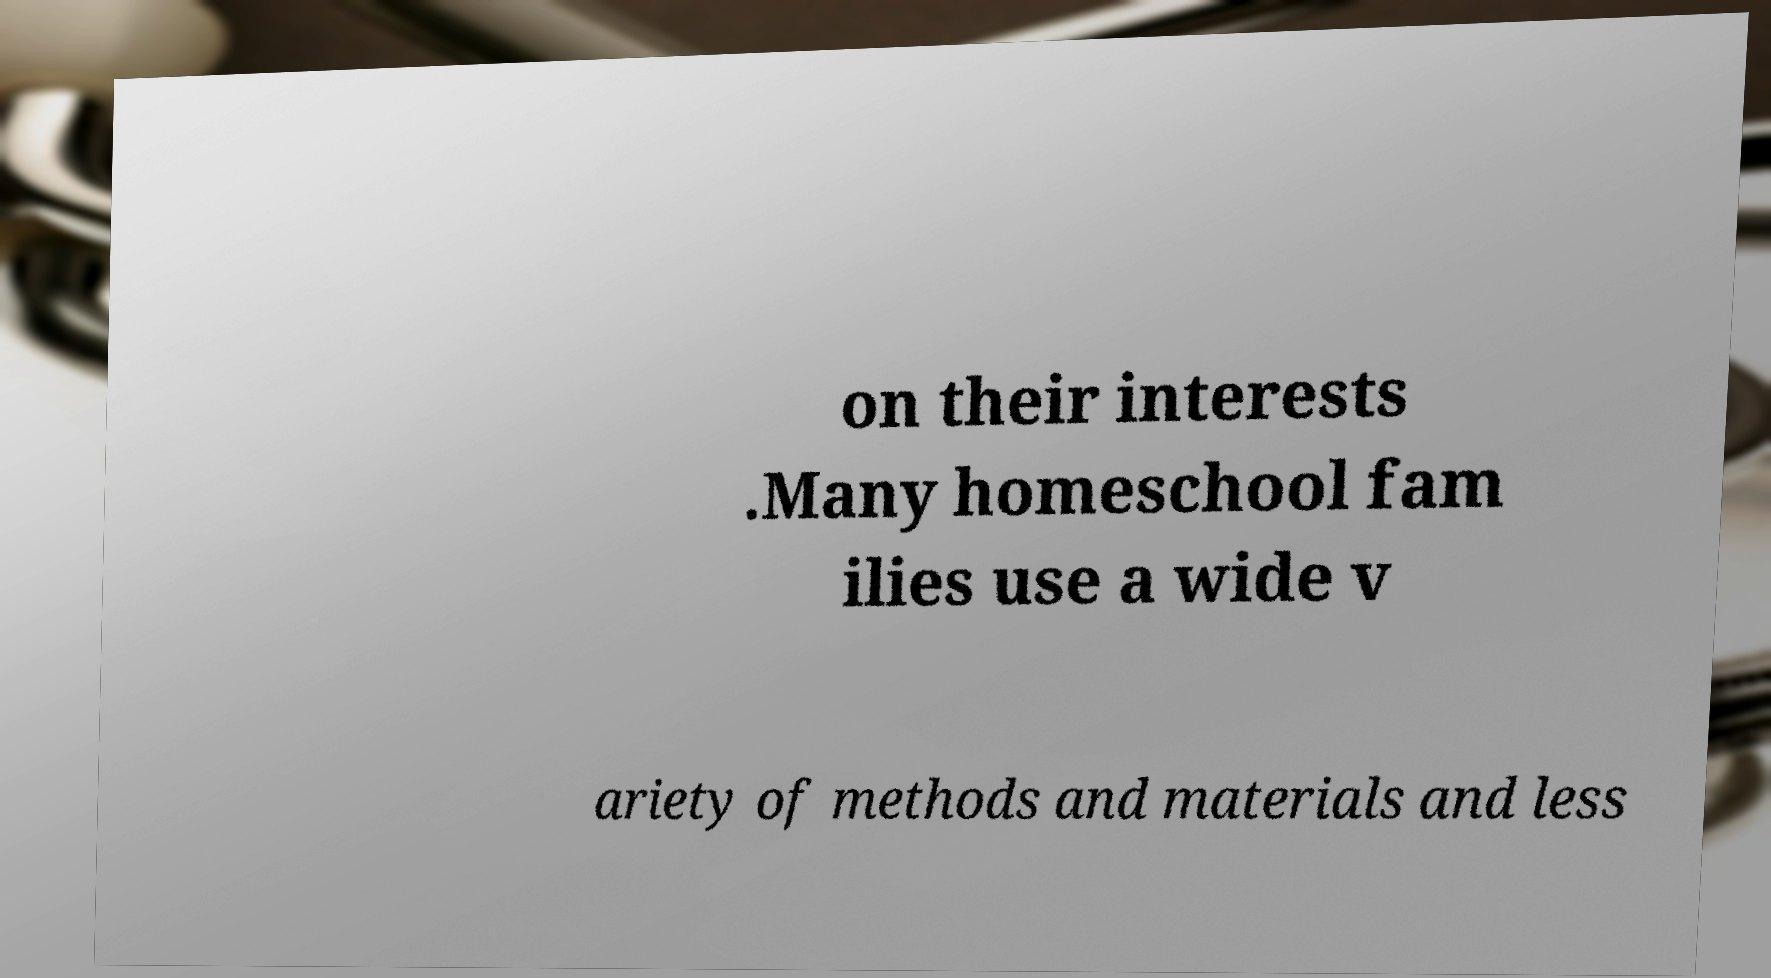Could you assist in decoding the text presented in this image and type it out clearly? on their interests .Many homeschool fam ilies use a wide v ariety of methods and materials and less 